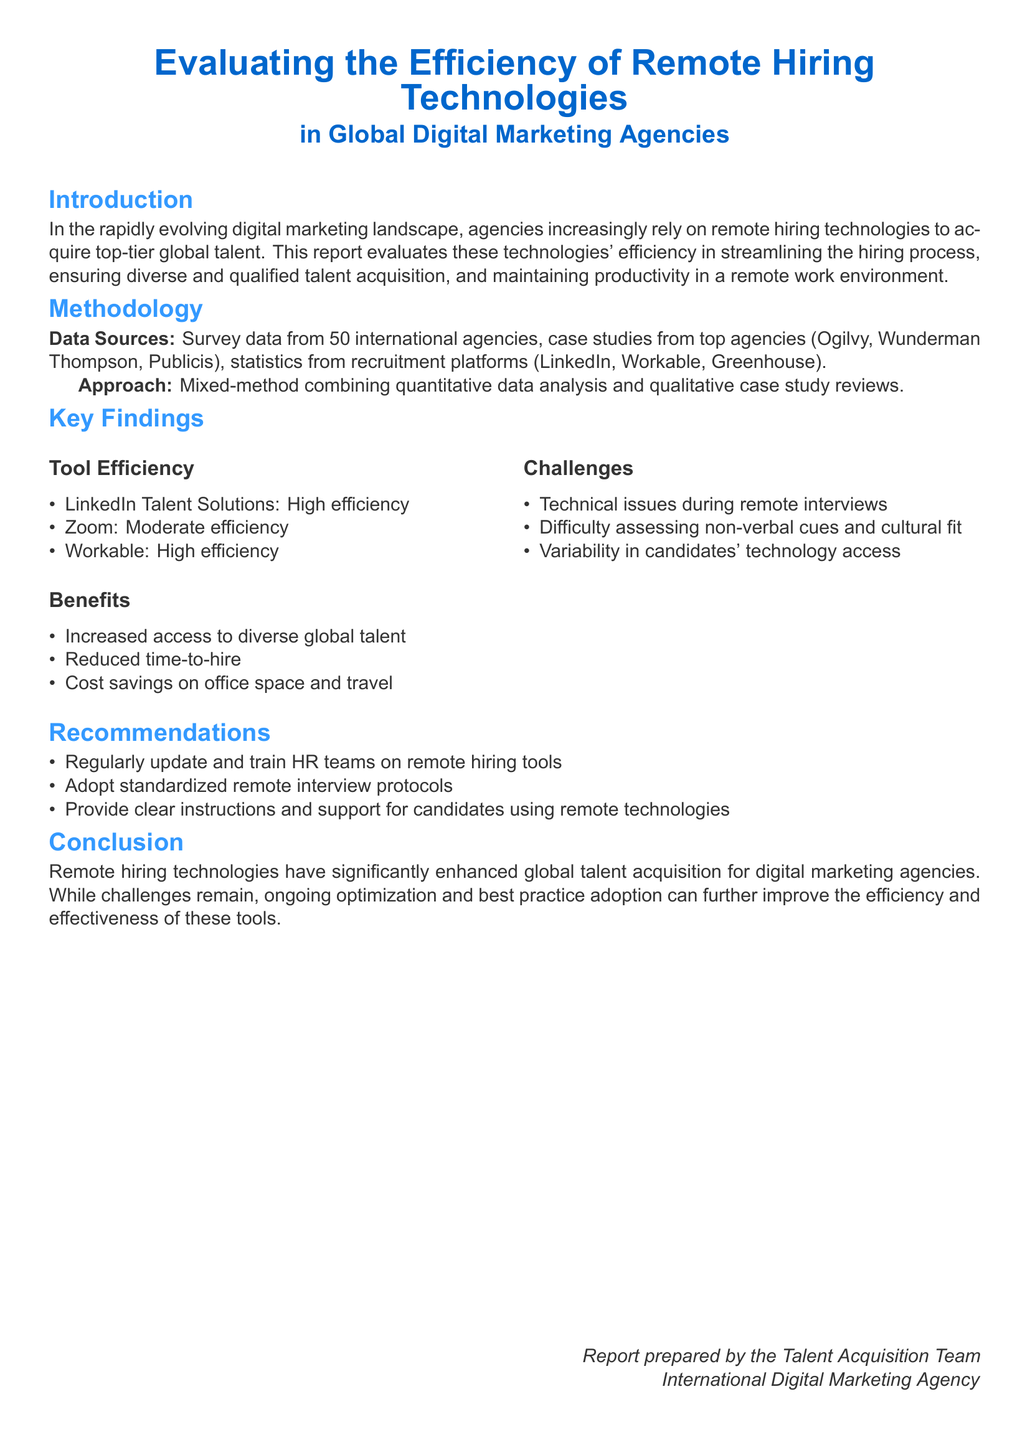What is the title of the report? The title of the report is stated at the beginning of the document and provides insight into its focus.
Answer: Evaluating the Efficiency of Remote Hiring Technologies in Global Digital Marketing Agencies How many international agencies participated in the survey? The number of agencies surveyed is specifically mentioned in the methodology section of the report.
Answer: 50 Which tool was noted for high efficiency? The findings highlight the efficiency ratings of various tools used in remote hiring.
Answer: LinkedIn Talent Solutions What is one benefit of using remote hiring technologies? The benefits section lists advantages of remote hiring for agencies, including one mention.
Answer: Increased access to diverse global talent What is a challenge mentioned regarding remote interviews? The report outlines challenges faced during remote interviews, including an important specific issue.
Answer: Technical issues during remote interviews What is a recommendation for HR teams? Recommendations for improving the efficiency of remote hiring tools are listed in a specific section of the report.
Answer: Regularly update and train HR teams on remote hiring tools Which agency was NOT listed as a case study source? The case studies section specifies the agencies that were reviewed, indicating one that is not included.
Answer: None (no other agencies listed) What was noted about the technology access of candidates? The challenges in assessing candidates include variability in their access to technology.
Answer: Variability in candidates' technology access 